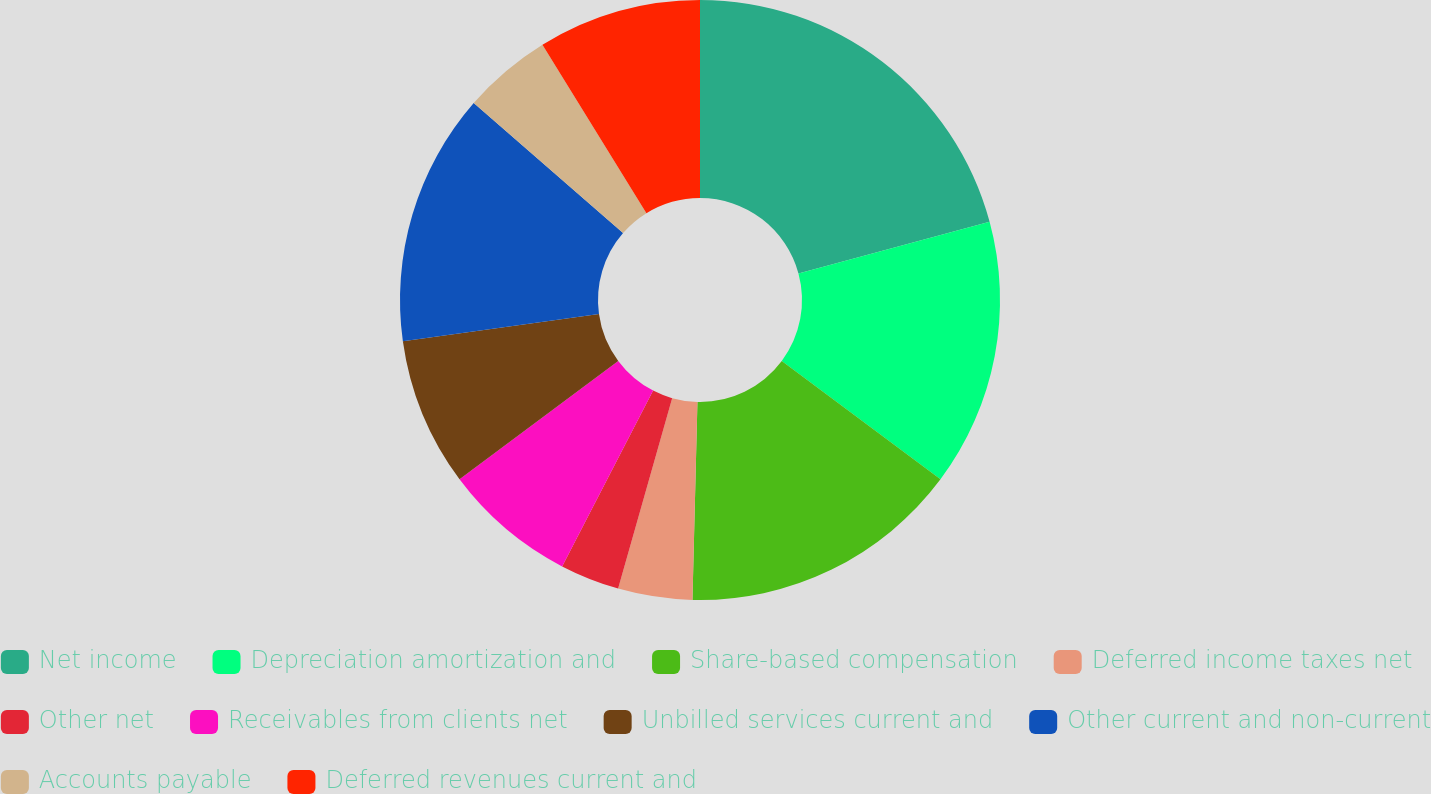Convert chart to OTSL. <chart><loc_0><loc_0><loc_500><loc_500><pie_chart><fcel>Net income<fcel>Depreciation amortization and<fcel>Share-based compensation<fcel>Deferred income taxes net<fcel>Other net<fcel>Receivables from clients net<fcel>Unbilled services current and<fcel>Other current and non-current<fcel>Accounts payable<fcel>Deferred revenues current and<nl><fcel>20.8%<fcel>14.4%<fcel>15.2%<fcel>4.0%<fcel>3.2%<fcel>7.2%<fcel>8.0%<fcel>13.6%<fcel>4.8%<fcel>8.8%<nl></chart> 